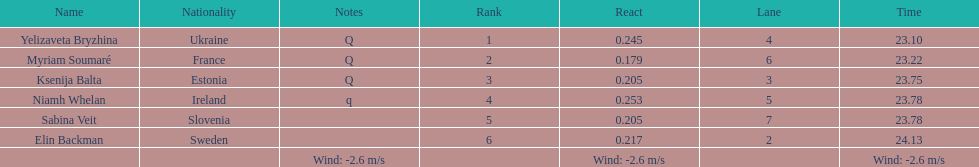What number of last names start with "b"? 3. 